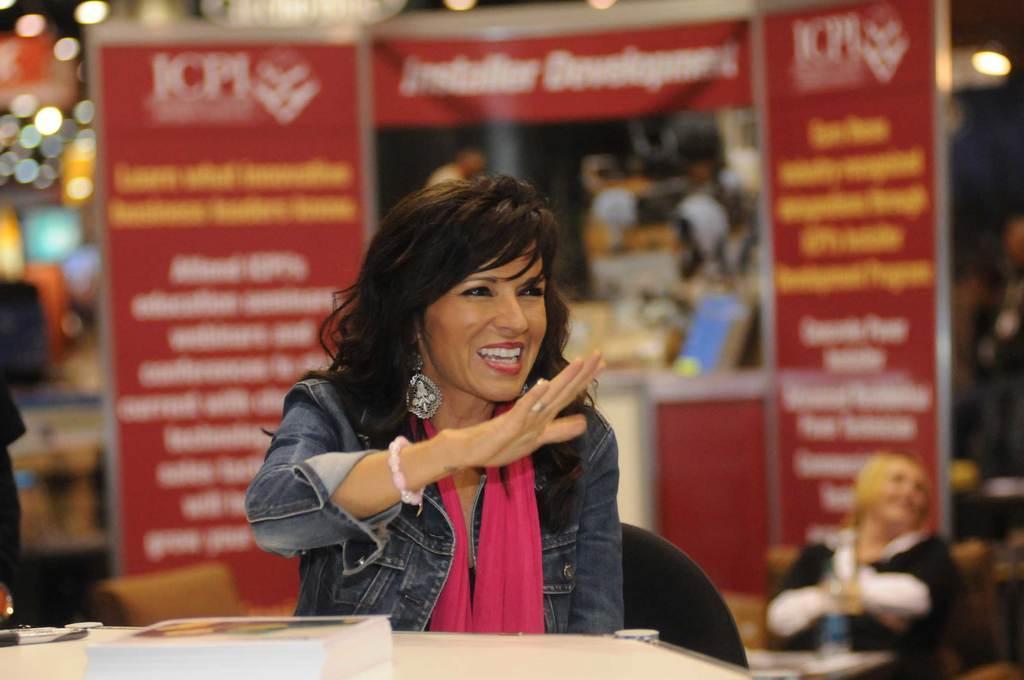Please provide a concise description of this image. In this image there is a lady sitting on chair in front of a table on which we can see there is a book, behind her there is a stall with so many banners on which we can see there is some note. 